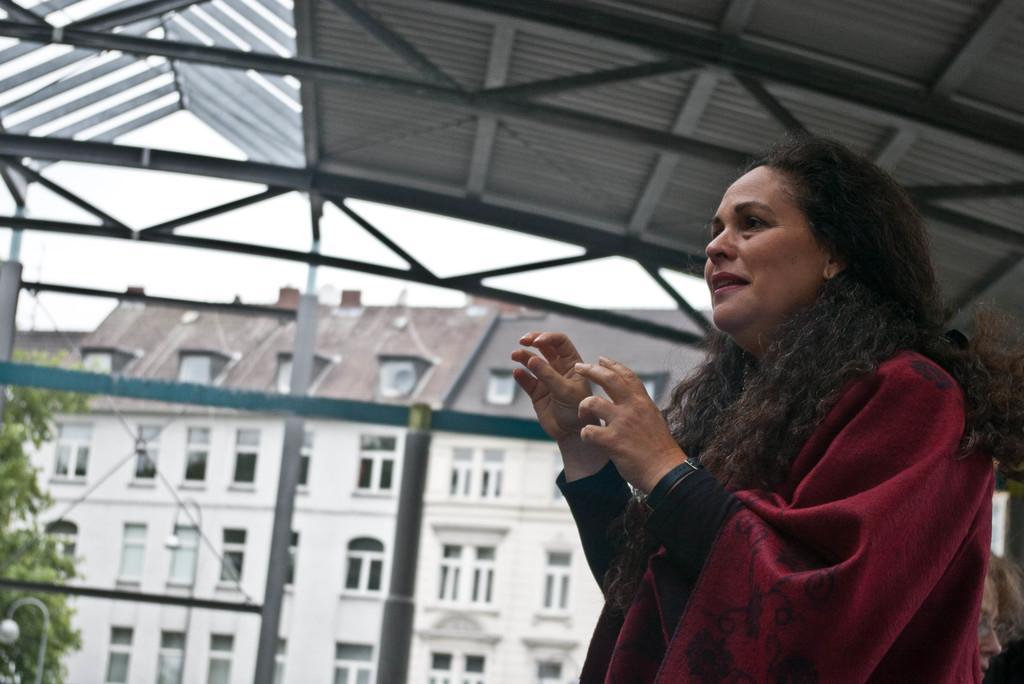Can you describe this image briefly? In this image I can see two people and one person wearing the black and maroon color dress. These people are are under the shed. In the background I can see the tree, pole,building with windows and the sky. 